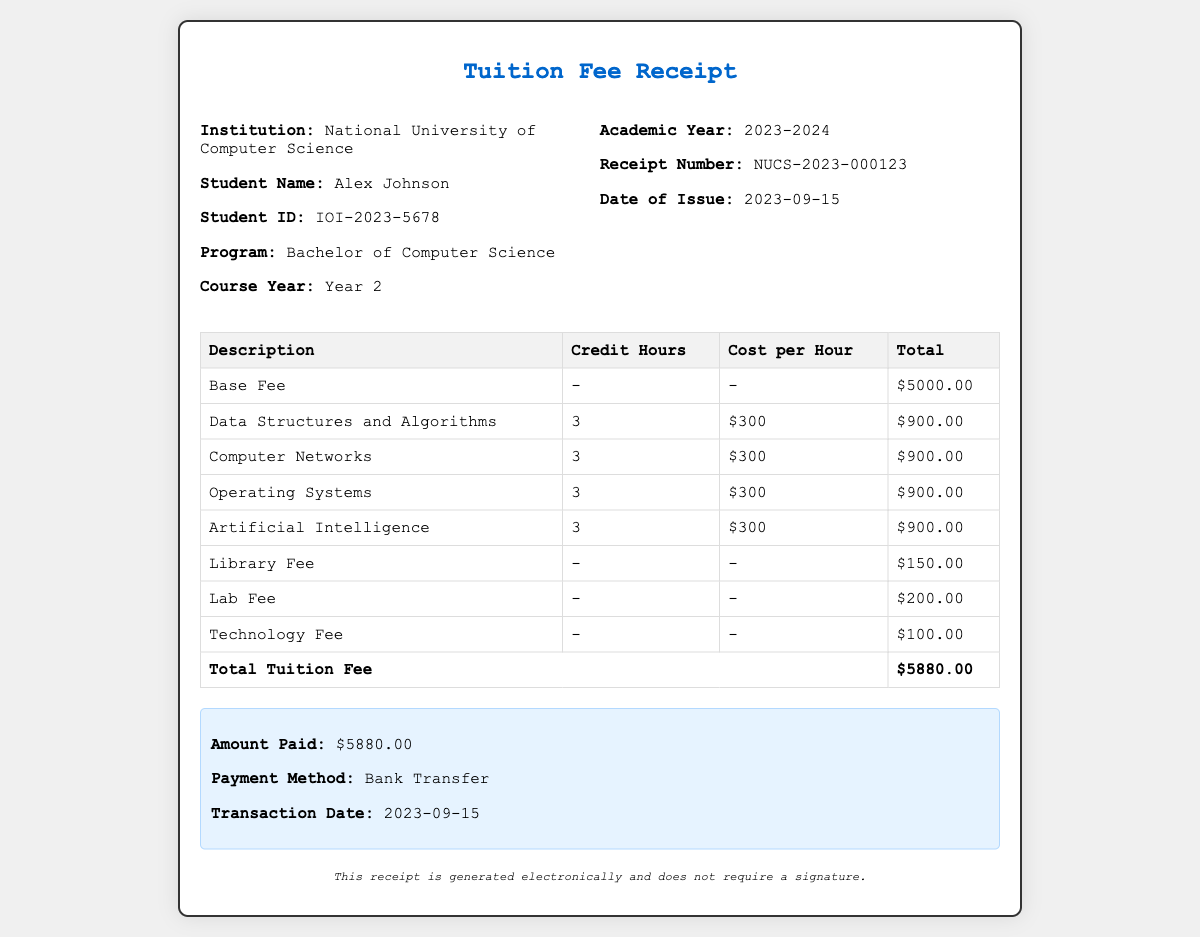What is the student's name? The student's name is provided in the document under the student info section.
Answer: Alex Johnson What is the total tuition fee? The total tuition fee is specified in the last row of the table in the document.
Answer: $5880.00 What is the payment method? The payment method is stated in the payment information section of the document.
Answer: Bank Transfer What is the receipt number? The receipt number is shown in the receipt info section of the document.
Answer: NUCS-2023-000123 How many courses are listed in the document? The number of courses can be counted from the table in the document, excluding the fees.
Answer: 4 What is the cost per hour for the courses? The cost per hour is indicated in each row of the table under the cost per hour column.
Answer: $300 What is the date of issue for the receipt? The date of issue is provided in the receipt info section of the document.
Answer: 2023-09-15 What is the institution's name? The institution's name is mentioned at the top of the document in the student info section.
Answer: National University of Computer Science What is the program of the student? The student's program is specified under the student info section of the document.
Answer: Bachelor of Computer Science 